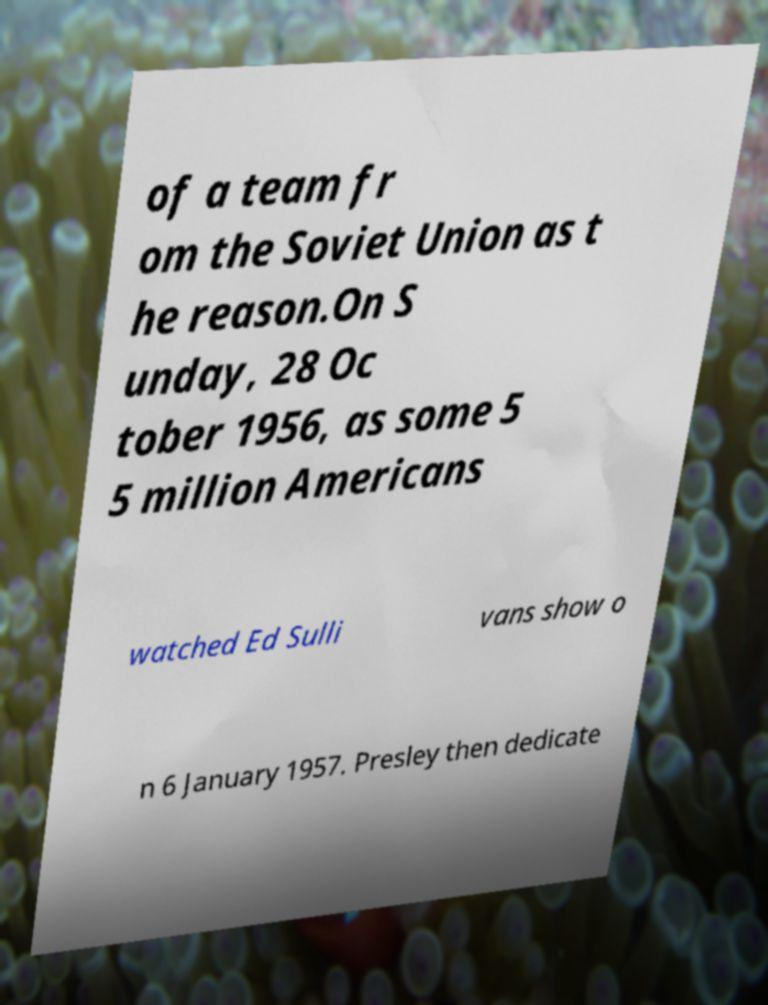Could you extract and type out the text from this image? of a team fr om the Soviet Union as t he reason.On S unday, 28 Oc tober 1956, as some 5 5 million Americans watched Ed Sulli vans show o n 6 January 1957. Presley then dedicate 